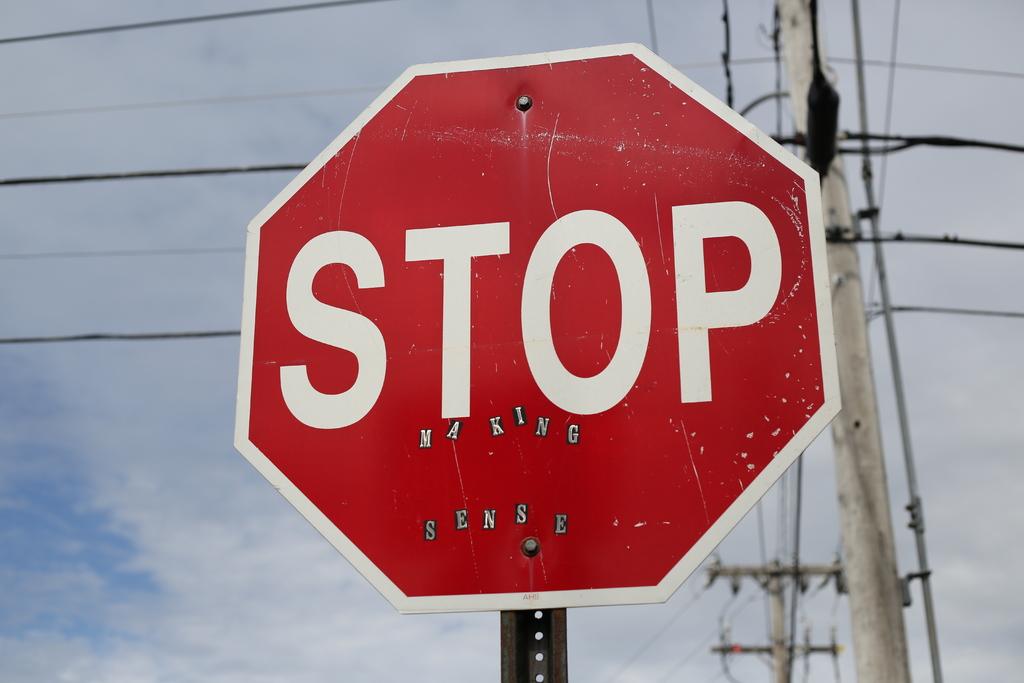What text did someone add to the stop sign?
Your answer should be very brief. Making sense. What is the original text of the sign?
Offer a very short reply. Stop. 